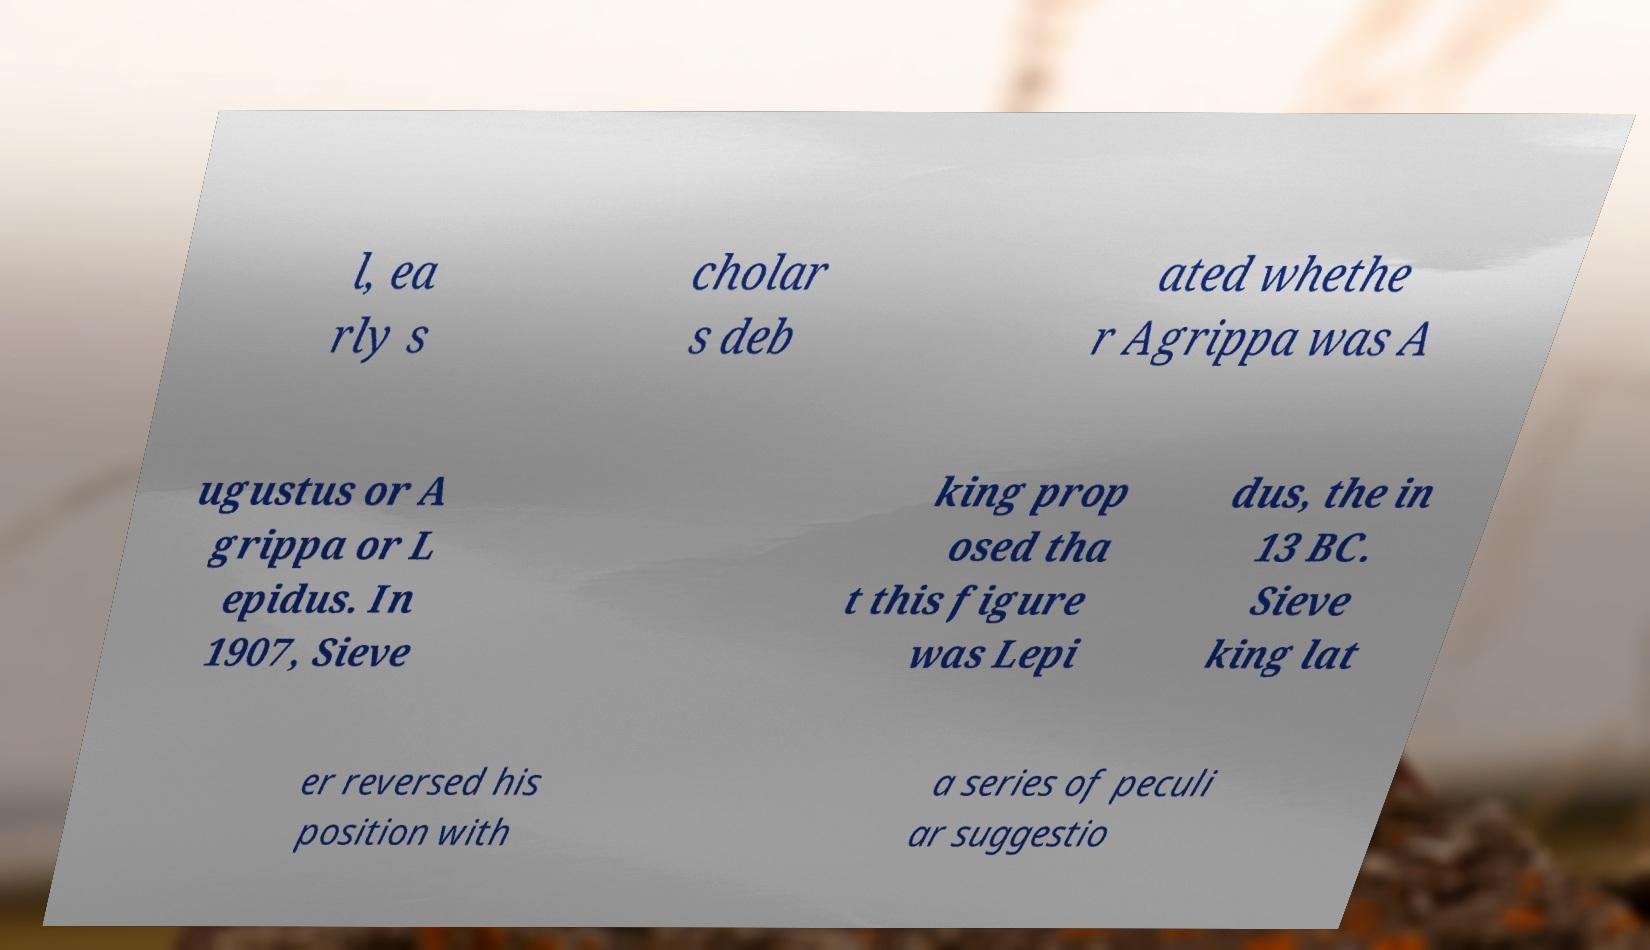What messages or text are displayed in this image? I need them in a readable, typed format. l, ea rly s cholar s deb ated whethe r Agrippa was A ugustus or A grippa or L epidus. In 1907, Sieve king prop osed tha t this figure was Lepi dus, the in 13 BC. Sieve king lat er reversed his position with a series of peculi ar suggestio 